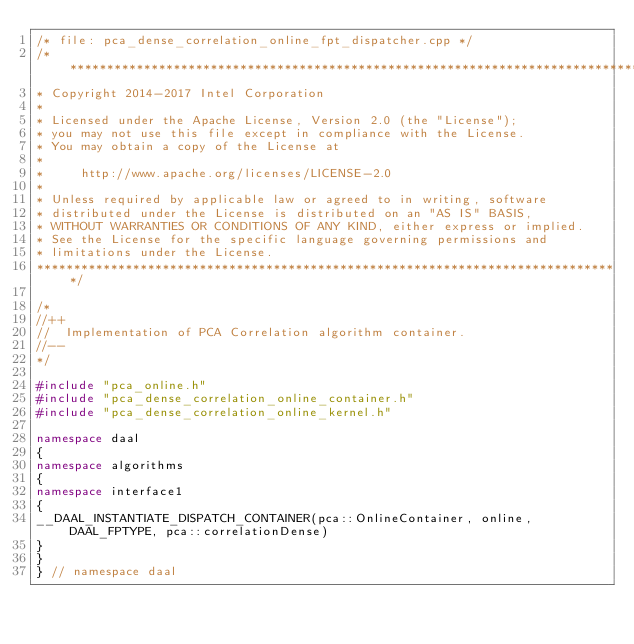<code> <loc_0><loc_0><loc_500><loc_500><_C++_>/* file: pca_dense_correlation_online_fpt_dispatcher.cpp */
/*******************************************************************************
* Copyright 2014-2017 Intel Corporation
*
* Licensed under the Apache License, Version 2.0 (the "License");
* you may not use this file except in compliance with the License.
* You may obtain a copy of the License at
*
*     http://www.apache.org/licenses/LICENSE-2.0
*
* Unless required by applicable law or agreed to in writing, software
* distributed under the License is distributed on an "AS IS" BASIS,
* WITHOUT WARRANTIES OR CONDITIONS OF ANY KIND, either express or implied.
* See the License for the specific language governing permissions and
* limitations under the License.
*******************************************************************************/

/*
//++
//  Implementation of PCA Correlation algorithm container.
//--
*/

#include "pca_online.h"
#include "pca_dense_correlation_online_container.h"
#include "pca_dense_correlation_online_kernel.h"

namespace daal
{
namespace algorithms
{
namespace interface1
{
__DAAL_INSTANTIATE_DISPATCH_CONTAINER(pca::OnlineContainer, online, DAAL_FPTYPE, pca::correlationDense)
}
}
} // namespace daal
</code> 